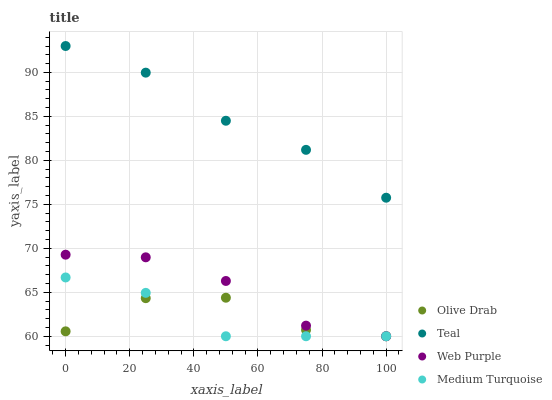Does Medium Turquoise have the minimum area under the curve?
Answer yes or no. Yes. Does Teal have the maximum area under the curve?
Answer yes or no. Yes. Does Olive Drab have the minimum area under the curve?
Answer yes or no. No. Does Olive Drab have the maximum area under the curve?
Answer yes or no. No. Is Teal the smoothest?
Answer yes or no. Yes. Is Olive Drab the roughest?
Answer yes or no. Yes. Is Olive Drab the smoothest?
Answer yes or no. No. Is Teal the roughest?
Answer yes or no. No. Does Web Purple have the lowest value?
Answer yes or no. Yes. Does Teal have the lowest value?
Answer yes or no. No. Does Teal have the highest value?
Answer yes or no. Yes. Does Olive Drab have the highest value?
Answer yes or no. No. Is Olive Drab less than Teal?
Answer yes or no. Yes. Is Teal greater than Olive Drab?
Answer yes or no. Yes. Does Medium Turquoise intersect Olive Drab?
Answer yes or no. Yes. Is Medium Turquoise less than Olive Drab?
Answer yes or no. No. Is Medium Turquoise greater than Olive Drab?
Answer yes or no. No. Does Olive Drab intersect Teal?
Answer yes or no. No. 